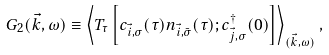Convert formula to latex. <formula><loc_0><loc_0><loc_500><loc_500>G _ { 2 } ( \vec { k } , \omega ) \equiv \left < T _ { \tau } \left [ c _ { \vec { i } , \sigma } ( \tau ) n _ { \vec { i } , \bar { \sigma } } ( \tau ) ; c ^ { \dagger } _ { \vec { j } , \sigma } ( 0 ) \right ] \right > _ { ( \vec { k } , \omega ) } ,</formula> 